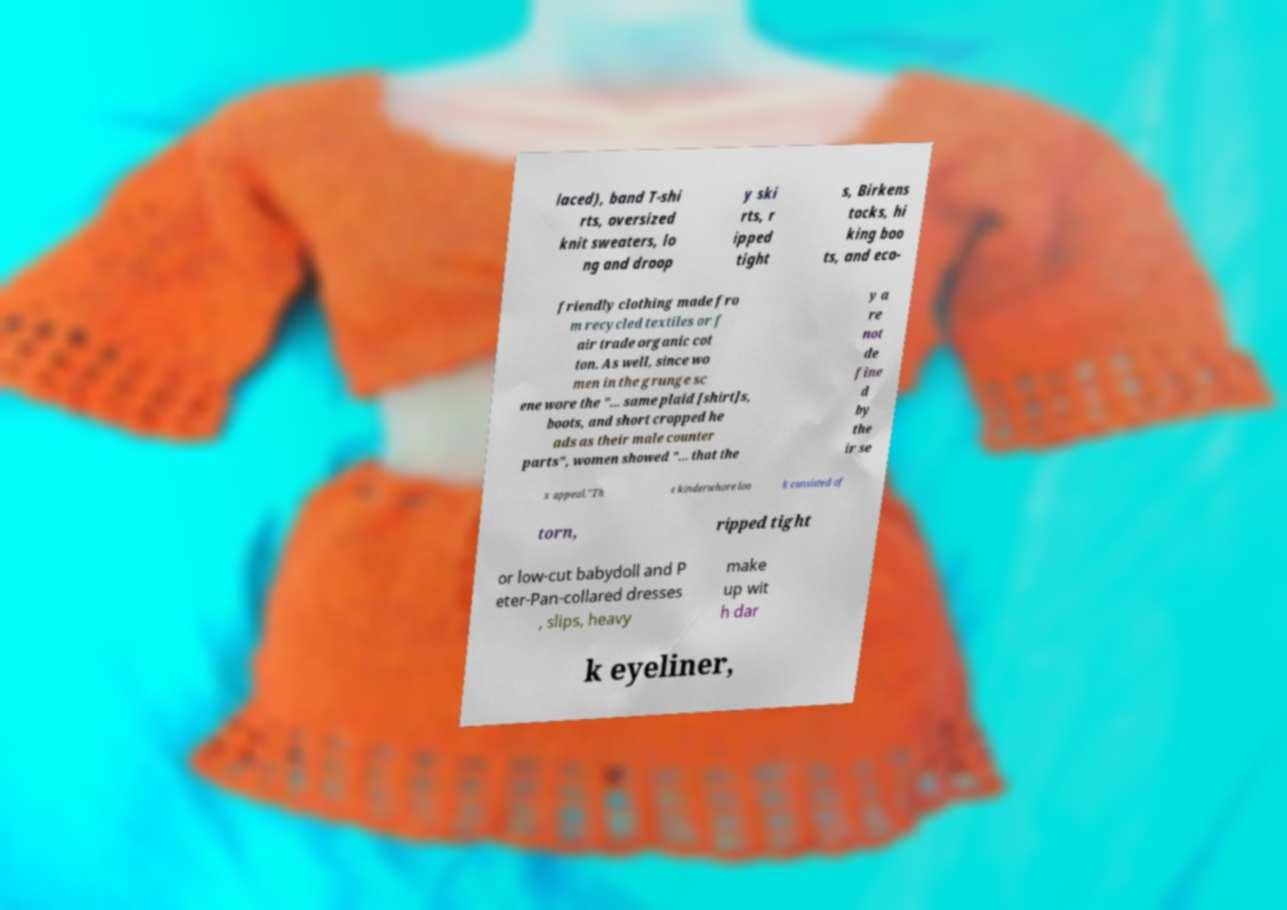Please identify and transcribe the text found in this image. laced), band T-shi rts, oversized knit sweaters, lo ng and droop y ski rts, r ipped tight s, Birkens tocks, hi king boo ts, and eco- friendly clothing made fro m recycled textiles or f air trade organic cot ton. As well, since wo men in the grunge sc ene wore the "... same plaid [shirt]s, boots, and short cropped he ads as their male counter parts", women showed "... that the y a re not de fine d by the ir se x appeal."Th e kinderwhore loo k consisted of torn, ripped tight or low-cut babydoll and P eter-Pan-collared dresses , slips, heavy make up wit h dar k eyeliner, 